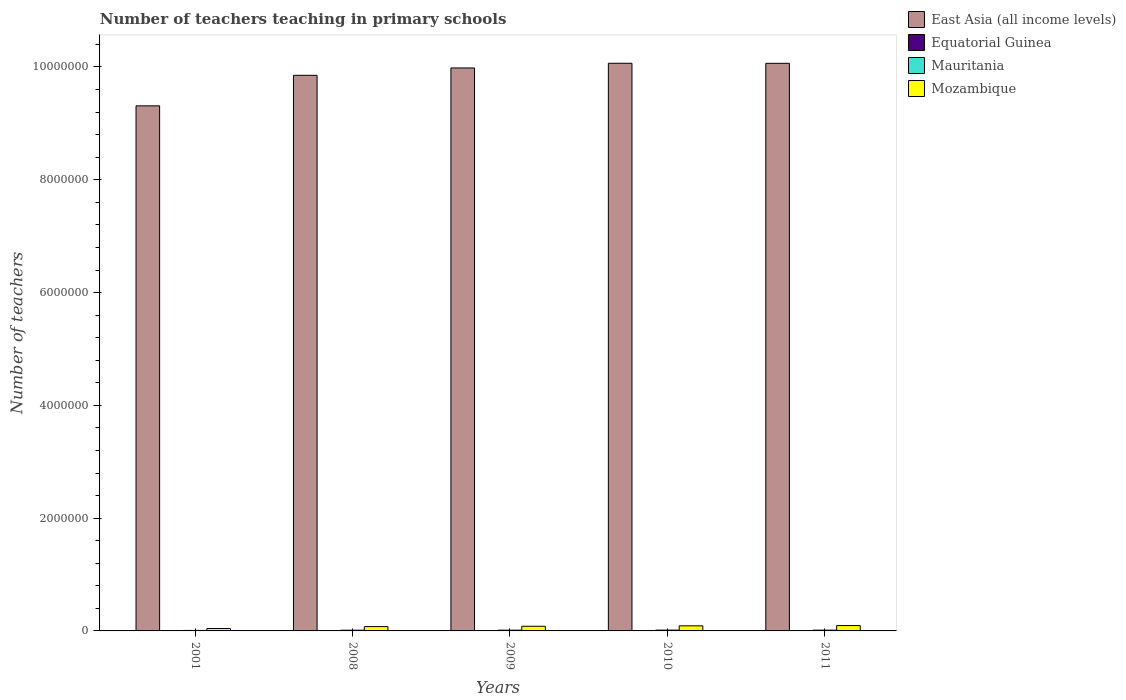How many different coloured bars are there?
Your response must be concise. 4. How many groups of bars are there?
Give a very brief answer. 5. Are the number of bars on each tick of the X-axis equal?
Give a very brief answer. Yes. How many bars are there on the 2nd tick from the left?
Offer a terse response. 4. What is the label of the 2nd group of bars from the left?
Ensure brevity in your answer.  2008. In how many cases, is the number of bars for a given year not equal to the number of legend labels?
Your answer should be compact. 0. What is the number of teachers teaching in primary schools in Mauritania in 2011?
Your response must be concise. 1.36e+04. Across all years, what is the maximum number of teachers teaching in primary schools in Mozambique?
Keep it short and to the point. 9.48e+04. Across all years, what is the minimum number of teachers teaching in primary schools in Mozambique?
Keep it short and to the point. 4.29e+04. What is the total number of teachers teaching in primary schools in Mauritania in the graph?
Ensure brevity in your answer.  6.24e+04. What is the difference between the number of teachers teaching in primary schools in Equatorial Guinea in 2008 and that in 2009?
Keep it short and to the point. -503. What is the difference between the number of teachers teaching in primary schools in East Asia (all income levels) in 2008 and the number of teachers teaching in primary schools in Mozambique in 2010?
Ensure brevity in your answer.  9.76e+06. What is the average number of teachers teaching in primary schools in Equatorial Guinea per year?
Your response must be concise. 2871. In the year 2010, what is the difference between the number of teachers teaching in primary schools in East Asia (all income levels) and number of teachers teaching in primary schools in Mozambique?
Offer a terse response. 9.98e+06. What is the ratio of the number of teachers teaching in primary schools in Mauritania in 2001 to that in 2010?
Give a very brief answer. 0.6. Is the difference between the number of teachers teaching in primary schools in East Asia (all income levels) in 2008 and 2009 greater than the difference between the number of teachers teaching in primary schools in Mozambique in 2008 and 2009?
Your answer should be very brief. No. What is the difference between the highest and the second highest number of teachers teaching in primary schools in Mauritania?
Make the answer very short. 663. What is the difference between the highest and the lowest number of teachers teaching in primary schools in Equatorial Guinea?
Offer a very short reply. 1593. In how many years, is the number of teachers teaching in primary schools in Mauritania greater than the average number of teachers teaching in primary schools in Mauritania taken over all years?
Your response must be concise. 4. Is it the case that in every year, the sum of the number of teachers teaching in primary schools in East Asia (all income levels) and number of teachers teaching in primary schools in Mozambique is greater than the sum of number of teachers teaching in primary schools in Equatorial Guinea and number of teachers teaching in primary schools in Mauritania?
Provide a succinct answer. Yes. What does the 3rd bar from the left in 2011 represents?
Make the answer very short. Mauritania. What does the 1st bar from the right in 2011 represents?
Provide a short and direct response. Mozambique. How many bars are there?
Your answer should be compact. 20. How many years are there in the graph?
Your answer should be very brief. 5. What is the difference between two consecutive major ticks on the Y-axis?
Offer a very short reply. 2.00e+06. Does the graph contain grids?
Offer a terse response. No. Where does the legend appear in the graph?
Your answer should be very brief. Top right. How many legend labels are there?
Offer a very short reply. 4. How are the legend labels stacked?
Offer a very short reply. Vertical. What is the title of the graph?
Offer a terse response. Number of teachers teaching in primary schools. Does "Cyprus" appear as one of the legend labels in the graph?
Keep it short and to the point. No. What is the label or title of the X-axis?
Offer a terse response. Years. What is the label or title of the Y-axis?
Provide a short and direct response. Number of teachers. What is the Number of teachers in East Asia (all income levels) in 2001?
Your answer should be compact. 9.31e+06. What is the Number of teachers of Equatorial Guinea in 2001?
Your answer should be very brief. 1810. What is the Number of teachers in Mauritania in 2001?
Provide a short and direct response. 8636. What is the Number of teachers in Mozambique in 2001?
Provide a succinct answer. 4.29e+04. What is the Number of teachers of East Asia (all income levels) in 2008?
Offer a very short reply. 9.85e+06. What is the Number of teachers in Equatorial Guinea in 2008?
Offer a very short reply. 2900. What is the Number of teachers in Mauritania in 2008?
Offer a very short reply. 1.27e+04. What is the Number of teachers of Mozambique in 2008?
Your response must be concise. 7.66e+04. What is the Number of teachers of East Asia (all income levels) in 2009?
Provide a short and direct response. 9.98e+06. What is the Number of teachers in Equatorial Guinea in 2009?
Provide a succinct answer. 3403. What is the Number of teachers of Mauritania in 2009?
Make the answer very short. 1.31e+04. What is the Number of teachers of Mozambique in 2009?
Your answer should be very brief. 8.28e+04. What is the Number of teachers in East Asia (all income levels) in 2010?
Your answer should be very brief. 1.01e+07. What is the Number of teachers in Equatorial Guinea in 2010?
Provide a short and direct response. 3131. What is the Number of teachers in Mauritania in 2010?
Ensure brevity in your answer.  1.43e+04. What is the Number of teachers in Mozambique in 2010?
Keep it short and to the point. 9.02e+04. What is the Number of teachers in East Asia (all income levels) in 2011?
Offer a very short reply. 1.01e+07. What is the Number of teachers of Equatorial Guinea in 2011?
Keep it short and to the point. 3111. What is the Number of teachers in Mauritania in 2011?
Offer a terse response. 1.36e+04. What is the Number of teachers of Mozambique in 2011?
Provide a short and direct response. 9.48e+04. Across all years, what is the maximum Number of teachers in East Asia (all income levels)?
Offer a terse response. 1.01e+07. Across all years, what is the maximum Number of teachers of Equatorial Guinea?
Make the answer very short. 3403. Across all years, what is the maximum Number of teachers in Mauritania?
Your answer should be very brief. 1.43e+04. Across all years, what is the maximum Number of teachers of Mozambique?
Give a very brief answer. 9.48e+04. Across all years, what is the minimum Number of teachers in East Asia (all income levels)?
Offer a very short reply. 9.31e+06. Across all years, what is the minimum Number of teachers in Equatorial Guinea?
Your answer should be compact. 1810. Across all years, what is the minimum Number of teachers in Mauritania?
Keep it short and to the point. 8636. Across all years, what is the minimum Number of teachers of Mozambique?
Provide a succinct answer. 4.29e+04. What is the total Number of teachers of East Asia (all income levels) in the graph?
Your answer should be very brief. 4.93e+07. What is the total Number of teachers in Equatorial Guinea in the graph?
Give a very brief answer. 1.44e+04. What is the total Number of teachers of Mauritania in the graph?
Provide a short and direct response. 6.24e+04. What is the total Number of teachers of Mozambique in the graph?
Offer a terse response. 3.87e+05. What is the difference between the Number of teachers in East Asia (all income levels) in 2001 and that in 2008?
Give a very brief answer. -5.41e+05. What is the difference between the Number of teachers in Equatorial Guinea in 2001 and that in 2008?
Your answer should be compact. -1090. What is the difference between the Number of teachers in Mauritania in 2001 and that in 2008?
Provide a succinct answer. -4088. What is the difference between the Number of teachers in Mozambique in 2001 and that in 2008?
Offer a very short reply. -3.36e+04. What is the difference between the Number of teachers in East Asia (all income levels) in 2001 and that in 2009?
Your answer should be very brief. -6.72e+05. What is the difference between the Number of teachers in Equatorial Guinea in 2001 and that in 2009?
Give a very brief answer. -1593. What is the difference between the Number of teachers in Mauritania in 2001 and that in 2009?
Provide a short and direct response. -4495. What is the difference between the Number of teachers of Mozambique in 2001 and that in 2009?
Give a very brief answer. -3.98e+04. What is the difference between the Number of teachers in East Asia (all income levels) in 2001 and that in 2010?
Your answer should be very brief. -7.55e+05. What is the difference between the Number of teachers in Equatorial Guinea in 2001 and that in 2010?
Your answer should be compact. -1321. What is the difference between the Number of teachers of Mauritania in 2001 and that in 2010?
Offer a terse response. -5667. What is the difference between the Number of teachers of Mozambique in 2001 and that in 2010?
Provide a short and direct response. -4.73e+04. What is the difference between the Number of teachers in East Asia (all income levels) in 2001 and that in 2011?
Offer a terse response. -7.54e+05. What is the difference between the Number of teachers of Equatorial Guinea in 2001 and that in 2011?
Offer a very short reply. -1301. What is the difference between the Number of teachers in Mauritania in 2001 and that in 2011?
Give a very brief answer. -5004. What is the difference between the Number of teachers of Mozambique in 2001 and that in 2011?
Ensure brevity in your answer.  -5.19e+04. What is the difference between the Number of teachers of East Asia (all income levels) in 2008 and that in 2009?
Make the answer very short. -1.30e+05. What is the difference between the Number of teachers of Equatorial Guinea in 2008 and that in 2009?
Make the answer very short. -503. What is the difference between the Number of teachers of Mauritania in 2008 and that in 2009?
Give a very brief answer. -407. What is the difference between the Number of teachers in Mozambique in 2008 and that in 2009?
Keep it short and to the point. -6195. What is the difference between the Number of teachers of East Asia (all income levels) in 2008 and that in 2010?
Provide a succinct answer. -2.13e+05. What is the difference between the Number of teachers in Equatorial Guinea in 2008 and that in 2010?
Offer a terse response. -231. What is the difference between the Number of teachers in Mauritania in 2008 and that in 2010?
Provide a succinct answer. -1579. What is the difference between the Number of teachers of Mozambique in 2008 and that in 2010?
Your answer should be very brief. -1.37e+04. What is the difference between the Number of teachers in East Asia (all income levels) in 2008 and that in 2011?
Keep it short and to the point. -2.12e+05. What is the difference between the Number of teachers in Equatorial Guinea in 2008 and that in 2011?
Offer a terse response. -211. What is the difference between the Number of teachers of Mauritania in 2008 and that in 2011?
Provide a succinct answer. -916. What is the difference between the Number of teachers of Mozambique in 2008 and that in 2011?
Provide a succinct answer. -1.82e+04. What is the difference between the Number of teachers in East Asia (all income levels) in 2009 and that in 2010?
Your answer should be very brief. -8.34e+04. What is the difference between the Number of teachers in Equatorial Guinea in 2009 and that in 2010?
Your answer should be compact. 272. What is the difference between the Number of teachers of Mauritania in 2009 and that in 2010?
Your response must be concise. -1172. What is the difference between the Number of teachers of Mozambique in 2009 and that in 2010?
Keep it short and to the point. -7483. What is the difference between the Number of teachers of East Asia (all income levels) in 2009 and that in 2011?
Make the answer very short. -8.23e+04. What is the difference between the Number of teachers of Equatorial Guinea in 2009 and that in 2011?
Your answer should be very brief. 292. What is the difference between the Number of teachers of Mauritania in 2009 and that in 2011?
Your response must be concise. -509. What is the difference between the Number of teachers of Mozambique in 2009 and that in 2011?
Provide a succinct answer. -1.20e+04. What is the difference between the Number of teachers of East Asia (all income levels) in 2010 and that in 2011?
Make the answer very short. 1032. What is the difference between the Number of teachers in Equatorial Guinea in 2010 and that in 2011?
Ensure brevity in your answer.  20. What is the difference between the Number of teachers of Mauritania in 2010 and that in 2011?
Provide a short and direct response. 663. What is the difference between the Number of teachers in Mozambique in 2010 and that in 2011?
Offer a very short reply. -4562. What is the difference between the Number of teachers in East Asia (all income levels) in 2001 and the Number of teachers in Equatorial Guinea in 2008?
Give a very brief answer. 9.31e+06. What is the difference between the Number of teachers of East Asia (all income levels) in 2001 and the Number of teachers of Mauritania in 2008?
Your response must be concise. 9.30e+06. What is the difference between the Number of teachers of East Asia (all income levels) in 2001 and the Number of teachers of Mozambique in 2008?
Provide a succinct answer. 9.23e+06. What is the difference between the Number of teachers in Equatorial Guinea in 2001 and the Number of teachers in Mauritania in 2008?
Provide a succinct answer. -1.09e+04. What is the difference between the Number of teachers of Equatorial Guinea in 2001 and the Number of teachers of Mozambique in 2008?
Ensure brevity in your answer.  -7.47e+04. What is the difference between the Number of teachers of Mauritania in 2001 and the Number of teachers of Mozambique in 2008?
Your response must be concise. -6.79e+04. What is the difference between the Number of teachers of East Asia (all income levels) in 2001 and the Number of teachers of Equatorial Guinea in 2009?
Offer a terse response. 9.31e+06. What is the difference between the Number of teachers of East Asia (all income levels) in 2001 and the Number of teachers of Mauritania in 2009?
Provide a short and direct response. 9.30e+06. What is the difference between the Number of teachers in East Asia (all income levels) in 2001 and the Number of teachers in Mozambique in 2009?
Provide a short and direct response. 9.23e+06. What is the difference between the Number of teachers in Equatorial Guinea in 2001 and the Number of teachers in Mauritania in 2009?
Offer a very short reply. -1.13e+04. What is the difference between the Number of teachers of Equatorial Guinea in 2001 and the Number of teachers of Mozambique in 2009?
Your answer should be compact. -8.09e+04. What is the difference between the Number of teachers of Mauritania in 2001 and the Number of teachers of Mozambique in 2009?
Give a very brief answer. -7.41e+04. What is the difference between the Number of teachers in East Asia (all income levels) in 2001 and the Number of teachers in Equatorial Guinea in 2010?
Keep it short and to the point. 9.31e+06. What is the difference between the Number of teachers of East Asia (all income levels) in 2001 and the Number of teachers of Mauritania in 2010?
Ensure brevity in your answer.  9.30e+06. What is the difference between the Number of teachers of East Asia (all income levels) in 2001 and the Number of teachers of Mozambique in 2010?
Make the answer very short. 9.22e+06. What is the difference between the Number of teachers of Equatorial Guinea in 2001 and the Number of teachers of Mauritania in 2010?
Offer a terse response. -1.25e+04. What is the difference between the Number of teachers of Equatorial Guinea in 2001 and the Number of teachers of Mozambique in 2010?
Keep it short and to the point. -8.84e+04. What is the difference between the Number of teachers of Mauritania in 2001 and the Number of teachers of Mozambique in 2010?
Your answer should be compact. -8.16e+04. What is the difference between the Number of teachers of East Asia (all income levels) in 2001 and the Number of teachers of Equatorial Guinea in 2011?
Give a very brief answer. 9.31e+06. What is the difference between the Number of teachers of East Asia (all income levels) in 2001 and the Number of teachers of Mauritania in 2011?
Offer a very short reply. 9.30e+06. What is the difference between the Number of teachers in East Asia (all income levels) in 2001 and the Number of teachers in Mozambique in 2011?
Ensure brevity in your answer.  9.22e+06. What is the difference between the Number of teachers in Equatorial Guinea in 2001 and the Number of teachers in Mauritania in 2011?
Your answer should be compact. -1.18e+04. What is the difference between the Number of teachers of Equatorial Guinea in 2001 and the Number of teachers of Mozambique in 2011?
Give a very brief answer. -9.30e+04. What is the difference between the Number of teachers of Mauritania in 2001 and the Number of teachers of Mozambique in 2011?
Make the answer very short. -8.62e+04. What is the difference between the Number of teachers in East Asia (all income levels) in 2008 and the Number of teachers in Equatorial Guinea in 2009?
Ensure brevity in your answer.  9.85e+06. What is the difference between the Number of teachers in East Asia (all income levels) in 2008 and the Number of teachers in Mauritania in 2009?
Provide a succinct answer. 9.84e+06. What is the difference between the Number of teachers in East Asia (all income levels) in 2008 and the Number of teachers in Mozambique in 2009?
Offer a terse response. 9.77e+06. What is the difference between the Number of teachers in Equatorial Guinea in 2008 and the Number of teachers in Mauritania in 2009?
Give a very brief answer. -1.02e+04. What is the difference between the Number of teachers in Equatorial Guinea in 2008 and the Number of teachers in Mozambique in 2009?
Make the answer very short. -7.99e+04. What is the difference between the Number of teachers of Mauritania in 2008 and the Number of teachers of Mozambique in 2009?
Offer a very short reply. -7.00e+04. What is the difference between the Number of teachers in East Asia (all income levels) in 2008 and the Number of teachers in Equatorial Guinea in 2010?
Offer a terse response. 9.85e+06. What is the difference between the Number of teachers in East Asia (all income levels) in 2008 and the Number of teachers in Mauritania in 2010?
Offer a terse response. 9.84e+06. What is the difference between the Number of teachers in East Asia (all income levels) in 2008 and the Number of teachers in Mozambique in 2010?
Provide a succinct answer. 9.76e+06. What is the difference between the Number of teachers of Equatorial Guinea in 2008 and the Number of teachers of Mauritania in 2010?
Make the answer very short. -1.14e+04. What is the difference between the Number of teachers of Equatorial Guinea in 2008 and the Number of teachers of Mozambique in 2010?
Give a very brief answer. -8.73e+04. What is the difference between the Number of teachers of Mauritania in 2008 and the Number of teachers of Mozambique in 2010?
Your answer should be very brief. -7.75e+04. What is the difference between the Number of teachers in East Asia (all income levels) in 2008 and the Number of teachers in Equatorial Guinea in 2011?
Your answer should be compact. 9.85e+06. What is the difference between the Number of teachers of East Asia (all income levels) in 2008 and the Number of teachers of Mauritania in 2011?
Ensure brevity in your answer.  9.84e+06. What is the difference between the Number of teachers of East Asia (all income levels) in 2008 and the Number of teachers of Mozambique in 2011?
Your answer should be very brief. 9.76e+06. What is the difference between the Number of teachers in Equatorial Guinea in 2008 and the Number of teachers in Mauritania in 2011?
Provide a succinct answer. -1.07e+04. What is the difference between the Number of teachers of Equatorial Guinea in 2008 and the Number of teachers of Mozambique in 2011?
Ensure brevity in your answer.  -9.19e+04. What is the difference between the Number of teachers of Mauritania in 2008 and the Number of teachers of Mozambique in 2011?
Offer a terse response. -8.21e+04. What is the difference between the Number of teachers in East Asia (all income levels) in 2009 and the Number of teachers in Equatorial Guinea in 2010?
Your answer should be very brief. 9.98e+06. What is the difference between the Number of teachers of East Asia (all income levels) in 2009 and the Number of teachers of Mauritania in 2010?
Give a very brief answer. 9.97e+06. What is the difference between the Number of teachers of East Asia (all income levels) in 2009 and the Number of teachers of Mozambique in 2010?
Your answer should be compact. 9.89e+06. What is the difference between the Number of teachers of Equatorial Guinea in 2009 and the Number of teachers of Mauritania in 2010?
Ensure brevity in your answer.  -1.09e+04. What is the difference between the Number of teachers of Equatorial Guinea in 2009 and the Number of teachers of Mozambique in 2010?
Provide a succinct answer. -8.68e+04. What is the difference between the Number of teachers in Mauritania in 2009 and the Number of teachers in Mozambique in 2010?
Offer a very short reply. -7.71e+04. What is the difference between the Number of teachers of East Asia (all income levels) in 2009 and the Number of teachers of Equatorial Guinea in 2011?
Keep it short and to the point. 9.98e+06. What is the difference between the Number of teachers in East Asia (all income levels) in 2009 and the Number of teachers in Mauritania in 2011?
Give a very brief answer. 9.97e+06. What is the difference between the Number of teachers of East Asia (all income levels) in 2009 and the Number of teachers of Mozambique in 2011?
Provide a short and direct response. 9.89e+06. What is the difference between the Number of teachers in Equatorial Guinea in 2009 and the Number of teachers in Mauritania in 2011?
Your response must be concise. -1.02e+04. What is the difference between the Number of teachers of Equatorial Guinea in 2009 and the Number of teachers of Mozambique in 2011?
Make the answer very short. -9.14e+04. What is the difference between the Number of teachers in Mauritania in 2009 and the Number of teachers in Mozambique in 2011?
Offer a terse response. -8.17e+04. What is the difference between the Number of teachers in East Asia (all income levels) in 2010 and the Number of teachers in Equatorial Guinea in 2011?
Your answer should be very brief. 1.01e+07. What is the difference between the Number of teachers of East Asia (all income levels) in 2010 and the Number of teachers of Mauritania in 2011?
Ensure brevity in your answer.  1.01e+07. What is the difference between the Number of teachers of East Asia (all income levels) in 2010 and the Number of teachers of Mozambique in 2011?
Provide a succinct answer. 9.97e+06. What is the difference between the Number of teachers of Equatorial Guinea in 2010 and the Number of teachers of Mauritania in 2011?
Your answer should be compact. -1.05e+04. What is the difference between the Number of teachers of Equatorial Guinea in 2010 and the Number of teachers of Mozambique in 2011?
Your answer should be compact. -9.17e+04. What is the difference between the Number of teachers in Mauritania in 2010 and the Number of teachers in Mozambique in 2011?
Ensure brevity in your answer.  -8.05e+04. What is the average Number of teachers of East Asia (all income levels) per year?
Make the answer very short. 9.86e+06. What is the average Number of teachers of Equatorial Guinea per year?
Make the answer very short. 2871. What is the average Number of teachers of Mauritania per year?
Ensure brevity in your answer.  1.25e+04. What is the average Number of teachers in Mozambique per year?
Your answer should be very brief. 7.75e+04. In the year 2001, what is the difference between the Number of teachers of East Asia (all income levels) and Number of teachers of Equatorial Guinea?
Give a very brief answer. 9.31e+06. In the year 2001, what is the difference between the Number of teachers in East Asia (all income levels) and Number of teachers in Mauritania?
Your answer should be very brief. 9.30e+06. In the year 2001, what is the difference between the Number of teachers in East Asia (all income levels) and Number of teachers in Mozambique?
Your response must be concise. 9.27e+06. In the year 2001, what is the difference between the Number of teachers of Equatorial Guinea and Number of teachers of Mauritania?
Offer a terse response. -6826. In the year 2001, what is the difference between the Number of teachers of Equatorial Guinea and Number of teachers of Mozambique?
Provide a succinct answer. -4.11e+04. In the year 2001, what is the difference between the Number of teachers in Mauritania and Number of teachers in Mozambique?
Keep it short and to the point. -3.43e+04. In the year 2008, what is the difference between the Number of teachers in East Asia (all income levels) and Number of teachers in Equatorial Guinea?
Offer a very short reply. 9.85e+06. In the year 2008, what is the difference between the Number of teachers of East Asia (all income levels) and Number of teachers of Mauritania?
Provide a succinct answer. 9.84e+06. In the year 2008, what is the difference between the Number of teachers of East Asia (all income levels) and Number of teachers of Mozambique?
Your response must be concise. 9.78e+06. In the year 2008, what is the difference between the Number of teachers of Equatorial Guinea and Number of teachers of Mauritania?
Your response must be concise. -9824. In the year 2008, what is the difference between the Number of teachers of Equatorial Guinea and Number of teachers of Mozambique?
Provide a short and direct response. -7.37e+04. In the year 2008, what is the difference between the Number of teachers in Mauritania and Number of teachers in Mozambique?
Ensure brevity in your answer.  -6.38e+04. In the year 2009, what is the difference between the Number of teachers of East Asia (all income levels) and Number of teachers of Equatorial Guinea?
Ensure brevity in your answer.  9.98e+06. In the year 2009, what is the difference between the Number of teachers of East Asia (all income levels) and Number of teachers of Mauritania?
Your answer should be very brief. 9.97e+06. In the year 2009, what is the difference between the Number of teachers in East Asia (all income levels) and Number of teachers in Mozambique?
Offer a very short reply. 9.90e+06. In the year 2009, what is the difference between the Number of teachers of Equatorial Guinea and Number of teachers of Mauritania?
Your response must be concise. -9728. In the year 2009, what is the difference between the Number of teachers of Equatorial Guinea and Number of teachers of Mozambique?
Provide a short and direct response. -7.94e+04. In the year 2009, what is the difference between the Number of teachers in Mauritania and Number of teachers in Mozambique?
Make the answer very short. -6.96e+04. In the year 2010, what is the difference between the Number of teachers in East Asia (all income levels) and Number of teachers in Equatorial Guinea?
Ensure brevity in your answer.  1.01e+07. In the year 2010, what is the difference between the Number of teachers in East Asia (all income levels) and Number of teachers in Mauritania?
Your answer should be very brief. 1.01e+07. In the year 2010, what is the difference between the Number of teachers of East Asia (all income levels) and Number of teachers of Mozambique?
Your response must be concise. 9.98e+06. In the year 2010, what is the difference between the Number of teachers of Equatorial Guinea and Number of teachers of Mauritania?
Ensure brevity in your answer.  -1.12e+04. In the year 2010, what is the difference between the Number of teachers in Equatorial Guinea and Number of teachers in Mozambique?
Give a very brief answer. -8.71e+04. In the year 2010, what is the difference between the Number of teachers in Mauritania and Number of teachers in Mozambique?
Provide a succinct answer. -7.59e+04. In the year 2011, what is the difference between the Number of teachers in East Asia (all income levels) and Number of teachers in Equatorial Guinea?
Provide a succinct answer. 1.01e+07. In the year 2011, what is the difference between the Number of teachers of East Asia (all income levels) and Number of teachers of Mauritania?
Your answer should be compact. 1.01e+07. In the year 2011, what is the difference between the Number of teachers in East Asia (all income levels) and Number of teachers in Mozambique?
Ensure brevity in your answer.  9.97e+06. In the year 2011, what is the difference between the Number of teachers in Equatorial Guinea and Number of teachers in Mauritania?
Provide a short and direct response. -1.05e+04. In the year 2011, what is the difference between the Number of teachers of Equatorial Guinea and Number of teachers of Mozambique?
Offer a very short reply. -9.17e+04. In the year 2011, what is the difference between the Number of teachers of Mauritania and Number of teachers of Mozambique?
Your answer should be very brief. -8.12e+04. What is the ratio of the Number of teachers in East Asia (all income levels) in 2001 to that in 2008?
Offer a very short reply. 0.94. What is the ratio of the Number of teachers of Equatorial Guinea in 2001 to that in 2008?
Offer a very short reply. 0.62. What is the ratio of the Number of teachers in Mauritania in 2001 to that in 2008?
Your answer should be compact. 0.68. What is the ratio of the Number of teachers of Mozambique in 2001 to that in 2008?
Provide a short and direct response. 0.56. What is the ratio of the Number of teachers of East Asia (all income levels) in 2001 to that in 2009?
Provide a short and direct response. 0.93. What is the ratio of the Number of teachers in Equatorial Guinea in 2001 to that in 2009?
Your answer should be very brief. 0.53. What is the ratio of the Number of teachers of Mauritania in 2001 to that in 2009?
Provide a short and direct response. 0.66. What is the ratio of the Number of teachers in Mozambique in 2001 to that in 2009?
Your answer should be compact. 0.52. What is the ratio of the Number of teachers of East Asia (all income levels) in 2001 to that in 2010?
Ensure brevity in your answer.  0.93. What is the ratio of the Number of teachers of Equatorial Guinea in 2001 to that in 2010?
Make the answer very short. 0.58. What is the ratio of the Number of teachers in Mauritania in 2001 to that in 2010?
Give a very brief answer. 0.6. What is the ratio of the Number of teachers in Mozambique in 2001 to that in 2010?
Provide a succinct answer. 0.48. What is the ratio of the Number of teachers in East Asia (all income levels) in 2001 to that in 2011?
Provide a short and direct response. 0.93. What is the ratio of the Number of teachers of Equatorial Guinea in 2001 to that in 2011?
Give a very brief answer. 0.58. What is the ratio of the Number of teachers of Mauritania in 2001 to that in 2011?
Make the answer very short. 0.63. What is the ratio of the Number of teachers of Mozambique in 2001 to that in 2011?
Give a very brief answer. 0.45. What is the ratio of the Number of teachers in East Asia (all income levels) in 2008 to that in 2009?
Offer a very short reply. 0.99. What is the ratio of the Number of teachers in Equatorial Guinea in 2008 to that in 2009?
Offer a very short reply. 0.85. What is the ratio of the Number of teachers in Mauritania in 2008 to that in 2009?
Provide a succinct answer. 0.97. What is the ratio of the Number of teachers in Mozambique in 2008 to that in 2009?
Offer a terse response. 0.93. What is the ratio of the Number of teachers of East Asia (all income levels) in 2008 to that in 2010?
Offer a very short reply. 0.98. What is the ratio of the Number of teachers of Equatorial Guinea in 2008 to that in 2010?
Your answer should be very brief. 0.93. What is the ratio of the Number of teachers of Mauritania in 2008 to that in 2010?
Ensure brevity in your answer.  0.89. What is the ratio of the Number of teachers in Mozambique in 2008 to that in 2010?
Provide a short and direct response. 0.85. What is the ratio of the Number of teachers of East Asia (all income levels) in 2008 to that in 2011?
Offer a very short reply. 0.98. What is the ratio of the Number of teachers of Equatorial Guinea in 2008 to that in 2011?
Your response must be concise. 0.93. What is the ratio of the Number of teachers in Mauritania in 2008 to that in 2011?
Provide a succinct answer. 0.93. What is the ratio of the Number of teachers in Mozambique in 2008 to that in 2011?
Offer a very short reply. 0.81. What is the ratio of the Number of teachers in East Asia (all income levels) in 2009 to that in 2010?
Your answer should be compact. 0.99. What is the ratio of the Number of teachers of Equatorial Guinea in 2009 to that in 2010?
Provide a succinct answer. 1.09. What is the ratio of the Number of teachers in Mauritania in 2009 to that in 2010?
Your response must be concise. 0.92. What is the ratio of the Number of teachers of Mozambique in 2009 to that in 2010?
Make the answer very short. 0.92. What is the ratio of the Number of teachers in Equatorial Guinea in 2009 to that in 2011?
Your answer should be compact. 1.09. What is the ratio of the Number of teachers in Mauritania in 2009 to that in 2011?
Offer a terse response. 0.96. What is the ratio of the Number of teachers of Mozambique in 2009 to that in 2011?
Your answer should be compact. 0.87. What is the ratio of the Number of teachers in East Asia (all income levels) in 2010 to that in 2011?
Give a very brief answer. 1. What is the ratio of the Number of teachers of Equatorial Guinea in 2010 to that in 2011?
Your answer should be compact. 1.01. What is the ratio of the Number of teachers of Mauritania in 2010 to that in 2011?
Keep it short and to the point. 1.05. What is the ratio of the Number of teachers of Mozambique in 2010 to that in 2011?
Your answer should be compact. 0.95. What is the difference between the highest and the second highest Number of teachers in East Asia (all income levels)?
Provide a short and direct response. 1032. What is the difference between the highest and the second highest Number of teachers of Equatorial Guinea?
Provide a short and direct response. 272. What is the difference between the highest and the second highest Number of teachers of Mauritania?
Make the answer very short. 663. What is the difference between the highest and the second highest Number of teachers in Mozambique?
Make the answer very short. 4562. What is the difference between the highest and the lowest Number of teachers of East Asia (all income levels)?
Offer a terse response. 7.55e+05. What is the difference between the highest and the lowest Number of teachers in Equatorial Guinea?
Offer a very short reply. 1593. What is the difference between the highest and the lowest Number of teachers in Mauritania?
Provide a succinct answer. 5667. What is the difference between the highest and the lowest Number of teachers in Mozambique?
Provide a succinct answer. 5.19e+04. 